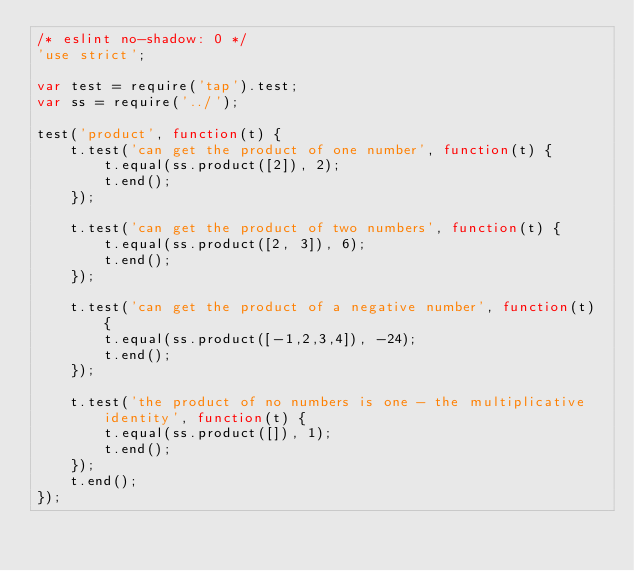<code> <loc_0><loc_0><loc_500><loc_500><_JavaScript_>/* eslint no-shadow: 0 */
'use strict';

var test = require('tap').test;
var ss = require('../');

test('product', function(t) {
    t.test('can get the product of one number', function(t) {
        t.equal(ss.product([2]), 2);
        t.end();
    });

    t.test('can get the product of two numbers', function(t) {
        t.equal(ss.product([2, 3]), 6);
        t.end();
    });

    t.test('can get the product of a negative number', function(t) {
        t.equal(ss.product([-1,2,3,4]), -24);
        t.end();
    });

    t.test('the product of no numbers is one - the multiplicative identity', function(t) {
        t.equal(ss.product([]), 1);
        t.end();
    });
    t.end();
});
</code> 